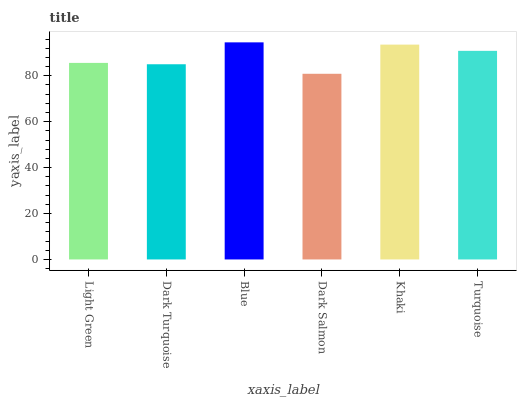Is Dark Salmon the minimum?
Answer yes or no. Yes. Is Blue the maximum?
Answer yes or no. Yes. Is Dark Turquoise the minimum?
Answer yes or no. No. Is Dark Turquoise the maximum?
Answer yes or no. No. Is Light Green greater than Dark Turquoise?
Answer yes or no. Yes. Is Dark Turquoise less than Light Green?
Answer yes or no. Yes. Is Dark Turquoise greater than Light Green?
Answer yes or no. No. Is Light Green less than Dark Turquoise?
Answer yes or no. No. Is Turquoise the high median?
Answer yes or no. Yes. Is Light Green the low median?
Answer yes or no. Yes. Is Blue the high median?
Answer yes or no. No. Is Dark Turquoise the low median?
Answer yes or no. No. 